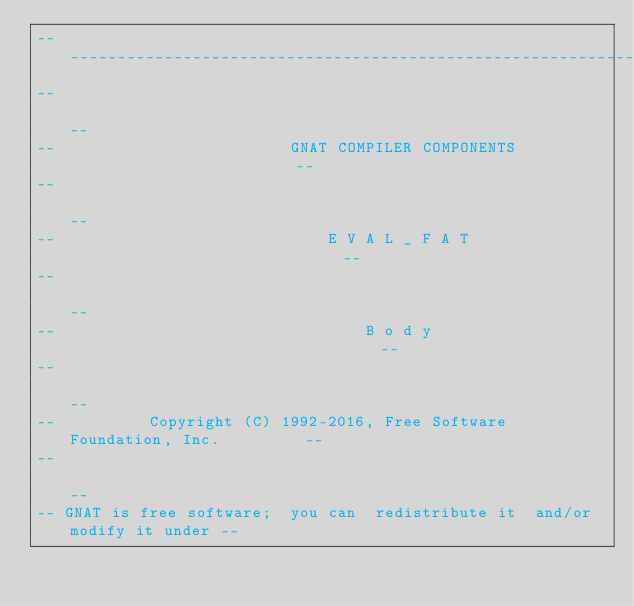<code> <loc_0><loc_0><loc_500><loc_500><_Ada_>------------------------------------------------------------------------------
--                                                                          --
--                         GNAT COMPILER COMPONENTS                         --
--                                                                          --
--                             E V A L _ F A T                              --
--                                                                          --
--                                 B o d y                                  --
--                                                                          --
--          Copyright (C) 1992-2016, Free Software Foundation, Inc.         --
--                                                                          --
-- GNAT is free software;  you can  redistribute it  and/or modify it under --</code> 